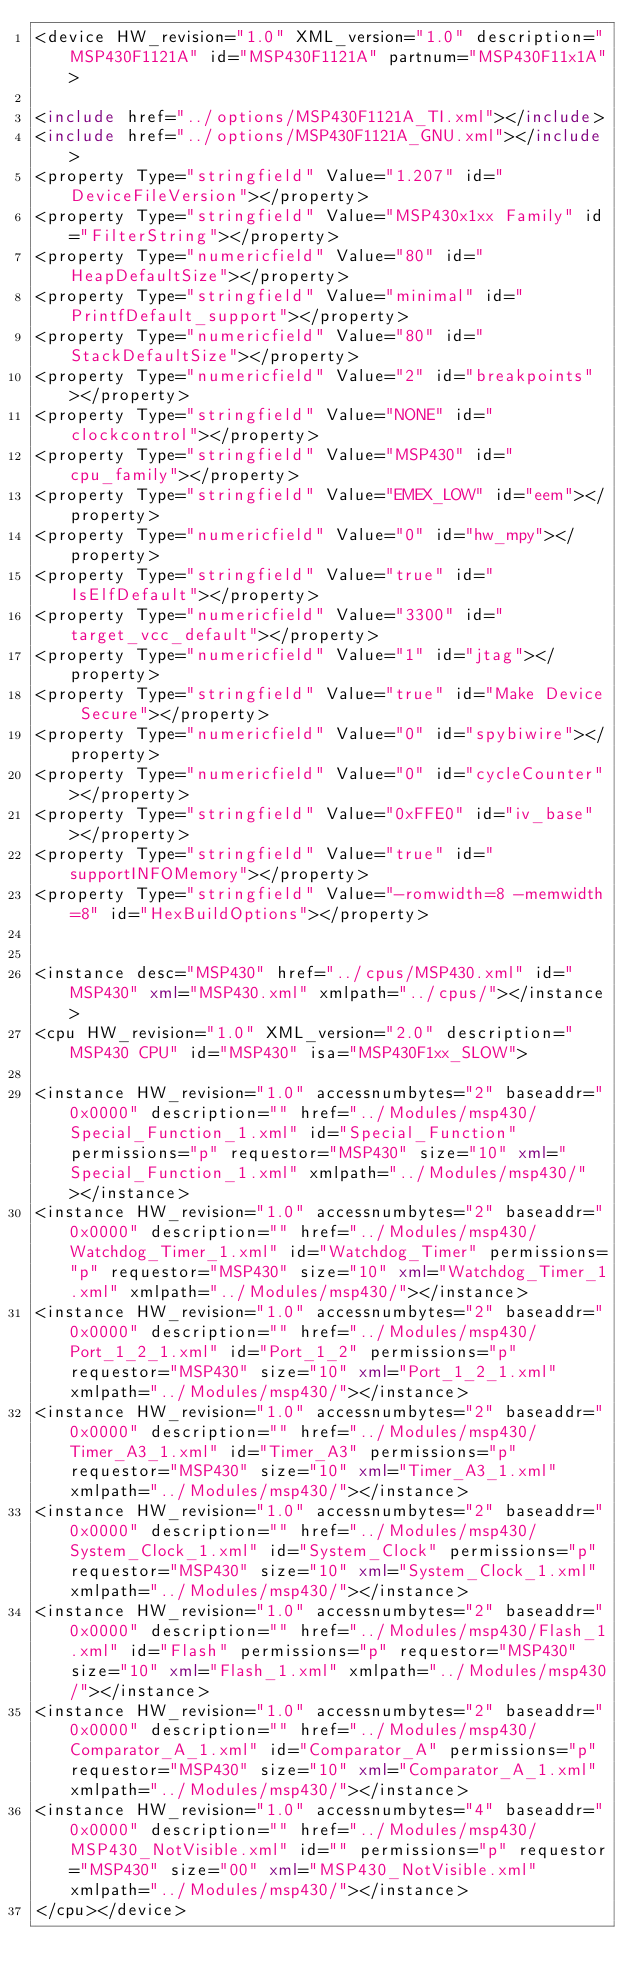<code> <loc_0><loc_0><loc_500><loc_500><_XML_><device HW_revision="1.0" XML_version="1.0" description="MSP430F1121A" id="MSP430F1121A" partnum="MSP430F11x1A">

<include href="../options/MSP430F1121A_TI.xml"></include>
<include href="../options/MSP430F1121A_GNU.xml"></include>
<property Type="stringfield" Value="1.207" id="DeviceFileVersion"></property>
<property Type="stringfield" Value="MSP430x1xx Family" id="FilterString"></property>
<property Type="numericfield" Value="80" id="HeapDefaultSize"></property>
<property Type="stringfield" Value="minimal" id="PrintfDefault_support"></property>
<property Type="numericfield" Value="80" id="StackDefaultSize"></property>
<property Type="numericfield" Value="2" id="breakpoints"></property>
<property Type="stringfield" Value="NONE" id="clockcontrol"></property>
<property Type="stringfield" Value="MSP430" id="cpu_family"></property>
<property Type="stringfield" Value="EMEX_LOW" id="eem"></property>
<property Type="numericfield" Value="0" id="hw_mpy"></property>
<property Type="stringfield" Value="true" id="IsElfDefault"></property>
<property Type="numericfield" Value="3300" id="target_vcc_default"></property>
<property Type="numericfield" Value="1" id="jtag"></property>
<property Type="stringfield" Value="true" id="Make Device Secure"></property>
<property Type="numericfield" Value="0" id="spybiwire"></property>
<property Type="numericfield" Value="0" id="cycleCounter"></property>
<property Type="stringfield" Value="0xFFE0" id="iv_base"></property>
<property Type="stringfield" Value="true" id="supportINFOMemory"></property>
<property Type="stringfield" Value="-romwidth=8 -memwidth=8" id="HexBuildOptions"></property>


<instance desc="MSP430" href="../cpus/MSP430.xml" id="MSP430" xml="MSP430.xml" xmlpath="../cpus/"></instance>
<cpu HW_revision="1.0" XML_version="2.0" description="MSP430 CPU" id="MSP430" isa="MSP430F1xx_SLOW">

<instance HW_revision="1.0" accessnumbytes="2" baseaddr="0x0000" description="" href="../Modules/msp430/Special_Function_1.xml" id="Special_Function" permissions="p" requestor="MSP430" size="10" xml="Special_Function_1.xml" xmlpath="../Modules/msp430/"></instance>
<instance HW_revision="1.0" accessnumbytes="2" baseaddr="0x0000" description="" href="../Modules/msp430/Watchdog_Timer_1.xml" id="Watchdog_Timer" permissions="p" requestor="MSP430" size="10" xml="Watchdog_Timer_1.xml" xmlpath="../Modules/msp430/"></instance>
<instance HW_revision="1.0" accessnumbytes="2" baseaddr="0x0000" description="" href="../Modules/msp430/Port_1_2_1.xml" id="Port_1_2" permissions="p" requestor="MSP430" size="10" xml="Port_1_2_1.xml" xmlpath="../Modules/msp430/"></instance>
<instance HW_revision="1.0" accessnumbytes="2" baseaddr="0x0000" description="" href="../Modules/msp430/Timer_A3_1.xml" id="Timer_A3" permissions="p" requestor="MSP430" size="10" xml="Timer_A3_1.xml" xmlpath="../Modules/msp430/"></instance>
<instance HW_revision="1.0" accessnumbytes="2" baseaddr="0x0000" description="" href="../Modules/msp430/System_Clock_1.xml" id="System_Clock" permissions="p" requestor="MSP430" size="10" xml="System_Clock_1.xml" xmlpath="../Modules/msp430/"></instance>
<instance HW_revision="1.0" accessnumbytes="2" baseaddr="0x0000" description="" href="../Modules/msp430/Flash_1.xml" id="Flash" permissions="p" requestor="MSP430" size="10" xml="Flash_1.xml" xmlpath="../Modules/msp430/"></instance>
<instance HW_revision="1.0" accessnumbytes="2" baseaddr="0x0000" description="" href="../Modules/msp430/Comparator_A_1.xml" id="Comparator_A" permissions="p" requestor="MSP430" size="10" xml="Comparator_A_1.xml" xmlpath="../Modules/msp430/"></instance>
<instance HW_revision="1.0" accessnumbytes="4" baseaddr="0x0000" description="" href="../Modules/msp430/MSP430_NotVisible.xml" id="" permissions="p" requestor="MSP430" size="00" xml="MSP430_NotVisible.xml" xmlpath="../Modules/msp430/"></instance>
</cpu></device></code> 